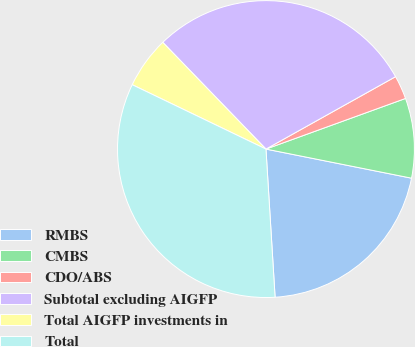Convert chart to OTSL. <chart><loc_0><loc_0><loc_500><loc_500><pie_chart><fcel>RMBS<fcel>CMBS<fcel>CDO/ABS<fcel>Subtotal excluding AIGFP<fcel>Total AIGFP investments in<fcel>Total<nl><fcel>20.88%<fcel>8.68%<fcel>2.57%<fcel>29.12%<fcel>5.63%<fcel>33.12%<nl></chart> 